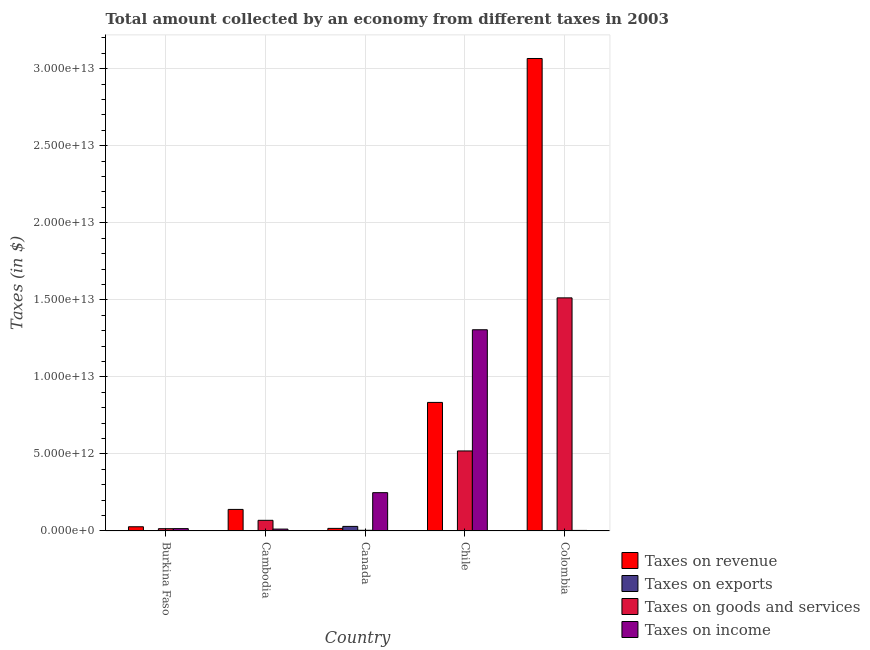How many different coloured bars are there?
Keep it short and to the point. 4. Are the number of bars per tick equal to the number of legend labels?
Your answer should be very brief. Yes. How many bars are there on the 4th tick from the right?
Your answer should be very brief. 4. What is the amount collected as tax on income in Chile?
Provide a succinct answer. 1.31e+13. Across all countries, what is the maximum amount collected as tax on income?
Your answer should be very brief. 1.31e+13. Across all countries, what is the minimum amount collected as tax on income?
Your answer should be very brief. 3.44e+1. In which country was the amount collected as tax on goods maximum?
Your answer should be very brief. Colombia. In which country was the amount collected as tax on exports minimum?
Your response must be concise. Chile. What is the total amount collected as tax on revenue in the graph?
Your answer should be very brief. 4.08e+13. What is the difference between the amount collected as tax on revenue in Burkina Faso and that in Colombia?
Offer a very short reply. -3.04e+13. What is the difference between the amount collected as tax on exports in Burkina Faso and the amount collected as tax on income in Canada?
Your answer should be compact. -2.48e+12. What is the average amount collected as tax on revenue per country?
Offer a terse response. 8.17e+12. What is the difference between the amount collected as tax on goods and amount collected as tax on revenue in Colombia?
Your answer should be compact. -1.55e+13. What is the ratio of the amount collected as tax on goods in Burkina Faso to that in Canada?
Offer a terse response. 3.5. Is the amount collected as tax on exports in Canada less than that in Chile?
Your answer should be very brief. No. What is the difference between the highest and the second highest amount collected as tax on revenue?
Offer a very short reply. 2.23e+13. What is the difference between the highest and the lowest amount collected as tax on goods?
Offer a terse response. 1.51e+13. In how many countries, is the amount collected as tax on goods greater than the average amount collected as tax on goods taken over all countries?
Your answer should be very brief. 2. Is it the case that in every country, the sum of the amount collected as tax on goods and amount collected as tax on revenue is greater than the sum of amount collected as tax on income and amount collected as tax on exports?
Offer a terse response. No. What does the 2nd bar from the left in Chile represents?
Provide a short and direct response. Taxes on exports. What does the 3rd bar from the right in Canada represents?
Keep it short and to the point. Taxes on exports. Are all the bars in the graph horizontal?
Ensure brevity in your answer.  No. How many countries are there in the graph?
Offer a very short reply. 5. What is the difference between two consecutive major ticks on the Y-axis?
Provide a short and direct response. 5.00e+12. Does the graph contain any zero values?
Provide a short and direct response. No. Where does the legend appear in the graph?
Ensure brevity in your answer.  Bottom right. What is the title of the graph?
Ensure brevity in your answer.  Total amount collected by an economy from different taxes in 2003. What is the label or title of the Y-axis?
Give a very brief answer. Taxes (in $). What is the Taxes (in $) in Taxes on revenue in Burkina Faso?
Your response must be concise. 2.71e+11. What is the Taxes (in $) in Taxes on exports in Burkina Faso?
Provide a short and direct response. 8.56e+08. What is the Taxes (in $) in Taxes on goods and services in Burkina Faso?
Keep it short and to the point. 1.47e+11. What is the Taxes (in $) in Taxes on income in Burkina Faso?
Offer a very short reply. 1.50e+11. What is the Taxes (in $) of Taxes on revenue in Cambodia?
Offer a very short reply. 1.40e+12. What is the Taxes (in $) of Taxes on exports in Cambodia?
Provide a succinct answer. 1.28e+09. What is the Taxes (in $) of Taxes on goods and services in Cambodia?
Offer a very short reply. 6.89e+11. What is the Taxes (in $) of Taxes on income in Cambodia?
Ensure brevity in your answer.  1.21e+11. What is the Taxes (in $) in Taxes on revenue in Canada?
Your answer should be compact. 1.66e+11. What is the Taxes (in $) in Taxes on exports in Canada?
Offer a terse response. 2.95e+11. What is the Taxes (in $) in Taxes on goods and services in Canada?
Ensure brevity in your answer.  4.21e+1. What is the Taxes (in $) in Taxes on income in Canada?
Your answer should be compact. 2.48e+12. What is the Taxes (in $) of Taxes on revenue in Chile?
Offer a terse response. 8.34e+12. What is the Taxes (in $) of Taxes on exports in Chile?
Your answer should be compact. 1.00e+06. What is the Taxes (in $) in Taxes on goods and services in Chile?
Offer a very short reply. 5.19e+12. What is the Taxes (in $) in Taxes on income in Chile?
Offer a very short reply. 1.31e+13. What is the Taxes (in $) of Taxes on revenue in Colombia?
Your answer should be very brief. 3.07e+13. What is the Taxes (in $) in Taxes on exports in Colombia?
Your response must be concise. 3.00e+06. What is the Taxes (in $) in Taxes on goods and services in Colombia?
Keep it short and to the point. 1.51e+13. What is the Taxes (in $) of Taxes on income in Colombia?
Provide a succinct answer. 3.44e+1. Across all countries, what is the maximum Taxes (in $) in Taxes on revenue?
Ensure brevity in your answer.  3.07e+13. Across all countries, what is the maximum Taxes (in $) of Taxes on exports?
Your answer should be compact. 2.95e+11. Across all countries, what is the maximum Taxes (in $) in Taxes on goods and services?
Offer a very short reply. 1.51e+13. Across all countries, what is the maximum Taxes (in $) of Taxes on income?
Your response must be concise. 1.31e+13. Across all countries, what is the minimum Taxes (in $) of Taxes on revenue?
Provide a short and direct response. 1.66e+11. Across all countries, what is the minimum Taxes (in $) in Taxes on exports?
Your answer should be compact. 1.00e+06. Across all countries, what is the minimum Taxes (in $) of Taxes on goods and services?
Your answer should be compact. 4.21e+1. Across all countries, what is the minimum Taxes (in $) in Taxes on income?
Your answer should be compact. 3.44e+1. What is the total Taxes (in $) of Taxes on revenue in the graph?
Make the answer very short. 4.08e+13. What is the total Taxes (in $) of Taxes on exports in the graph?
Offer a terse response. 2.97e+11. What is the total Taxes (in $) in Taxes on goods and services in the graph?
Your answer should be very brief. 2.12e+13. What is the total Taxes (in $) of Taxes on income in the graph?
Ensure brevity in your answer.  1.58e+13. What is the difference between the Taxes (in $) in Taxes on revenue in Burkina Faso and that in Cambodia?
Keep it short and to the point. -1.13e+12. What is the difference between the Taxes (in $) of Taxes on exports in Burkina Faso and that in Cambodia?
Offer a very short reply. -4.27e+08. What is the difference between the Taxes (in $) in Taxes on goods and services in Burkina Faso and that in Cambodia?
Offer a terse response. -5.42e+11. What is the difference between the Taxes (in $) in Taxes on income in Burkina Faso and that in Cambodia?
Ensure brevity in your answer.  2.99e+1. What is the difference between the Taxes (in $) in Taxes on revenue in Burkina Faso and that in Canada?
Keep it short and to the point. 1.05e+11. What is the difference between the Taxes (in $) in Taxes on exports in Burkina Faso and that in Canada?
Provide a short and direct response. -2.94e+11. What is the difference between the Taxes (in $) of Taxes on goods and services in Burkina Faso and that in Canada?
Provide a succinct answer. 1.05e+11. What is the difference between the Taxes (in $) of Taxes on income in Burkina Faso and that in Canada?
Your answer should be compact. -2.33e+12. What is the difference between the Taxes (in $) in Taxes on revenue in Burkina Faso and that in Chile?
Your answer should be very brief. -8.07e+12. What is the difference between the Taxes (in $) in Taxes on exports in Burkina Faso and that in Chile?
Make the answer very short. 8.55e+08. What is the difference between the Taxes (in $) in Taxes on goods and services in Burkina Faso and that in Chile?
Provide a succinct answer. -5.04e+12. What is the difference between the Taxes (in $) of Taxes on income in Burkina Faso and that in Chile?
Your answer should be compact. -1.29e+13. What is the difference between the Taxes (in $) in Taxes on revenue in Burkina Faso and that in Colombia?
Keep it short and to the point. -3.04e+13. What is the difference between the Taxes (in $) in Taxes on exports in Burkina Faso and that in Colombia?
Ensure brevity in your answer.  8.53e+08. What is the difference between the Taxes (in $) of Taxes on goods and services in Burkina Faso and that in Colombia?
Provide a succinct answer. -1.50e+13. What is the difference between the Taxes (in $) in Taxes on income in Burkina Faso and that in Colombia?
Provide a short and direct response. 1.16e+11. What is the difference between the Taxes (in $) of Taxes on revenue in Cambodia and that in Canada?
Provide a succinct answer. 1.23e+12. What is the difference between the Taxes (in $) of Taxes on exports in Cambodia and that in Canada?
Your answer should be very brief. -2.94e+11. What is the difference between the Taxes (in $) in Taxes on goods and services in Cambodia and that in Canada?
Your response must be concise. 6.47e+11. What is the difference between the Taxes (in $) of Taxes on income in Cambodia and that in Canada?
Your response must be concise. -2.36e+12. What is the difference between the Taxes (in $) in Taxes on revenue in Cambodia and that in Chile?
Your answer should be compact. -6.94e+12. What is the difference between the Taxes (in $) of Taxes on exports in Cambodia and that in Chile?
Offer a terse response. 1.28e+09. What is the difference between the Taxes (in $) of Taxes on goods and services in Cambodia and that in Chile?
Your answer should be very brief. -4.50e+12. What is the difference between the Taxes (in $) of Taxes on income in Cambodia and that in Chile?
Offer a very short reply. -1.29e+13. What is the difference between the Taxes (in $) of Taxes on revenue in Cambodia and that in Colombia?
Ensure brevity in your answer.  -2.93e+13. What is the difference between the Taxes (in $) of Taxes on exports in Cambodia and that in Colombia?
Provide a succinct answer. 1.28e+09. What is the difference between the Taxes (in $) in Taxes on goods and services in Cambodia and that in Colombia?
Offer a terse response. -1.44e+13. What is the difference between the Taxes (in $) of Taxes on income in Cambodia and that in Colombia?
Ensure brevity in your answer.  8.62e+1. What is the difference between the Taxes (in $) in Taxes on revenue in Canada and that in Chile?
Offer a very short reply. -8.18e+12. What is the difference between the Taxes (in $) in Taxes on exports in Canada and that in Chile?
Make the answer very short. 2.95e+11. What is the difference between the Taxes (in $) of Taxes on goods and services in Canada and that in Chile?
Give a very brief answer. -5.15e+12. What is the difference between the Taxes (in $) in Taxes on income in Canada and that in Chile?
Your answer should be very brief. -1.06e+13. What is the difference between the Taxes (in $) of Taxes on revenue in Canada and that in Colombia?
Offer a very short reply. -3.05e+13. What is the difference between the Taxes (in $) of Taxes on exports in Canada and that in Colombia?
Keep it short and to the point. 2.95e+11. What is the difference between the Taxes (in $) in Taxes on goods and services in Canada and that in Colombia?
Give a very brief answer. -1.51e+13. What is the difference between the Taxes (in $) in Taxes on income in Canada and that in Colombia?
Your answer should be very brief. 2.45e+12. What is the difference between the Taxes (in $) of Taxes on revenue in Chile and that in Colombia?
Offer a very short reply. -2.23e+13. What is the difference between the Taxes (in $) of Taxes on exports in Chile and that in Colombia?
Make the answer very short. -2.00e+06. What is the difference between the Taxes (in $) in Taxes on goods and services in Chile and that in Colombia?
Make the answer very short. -9.93e+12. What is the difference between the Taxes (in $) in Taxes on income in Chile and that in Colombia?
Provide a short and direct response. 1.30e+13. What is the difference between the Taxes (in $) of Taxes on revenue in Burkina Faso and the Taxes (in $) of Taxes on exports in Cambodia?
Give a very brief answer. 2.70e+11. What is the difference between the Taxes (in $) of Taxes on revenue in Burkina Faso and the Taxes (in $) of Taxes on goods and services in Cambodia?
Provide a short and direct response. -4.18e+11. What is the difference between the Taxes (in $) in Taxes on revenue in Burkina Faso and the Taxes (in $) in Taxes on income in Cambodia?
Offer a very short reply. 1.51e+11. What is the difference between the Taxes (in $) of Taxes on exports in Burkina Faso and the Taxes (in $) of Taxes on goods and services in Cambodia?
Keep it short and to the point. -6.89e+11. What is the difference between the Taxes (in $) of Taxes on exports in Burkina Faso and the Taxes (in $) of Taxes on income in Cambodia?
Your answer should be very brief. -1.20e+11. What is the difference between the Taxes (in $) of Taxes on goods and services in Burkina Faso and the Taxes (in $) of Taxes on income in Cambodia?
Provide a succinct answer. 2.67e+1. What is the difference between the Taxes (in $) in Taxes on revenue in Burkina Faso and the Taxes (in $) in Taxes on exports in Canada?
Make the answer very short. -2.37e+1. What is the difference between the Taxes (in $) in Taxes on revenue in Burkina Faso and the Taxes (in $) in Taxes on goods and services in Canada?
Your response must be concise. 2.29e+11. What is the difference between the Taxes (in $) in Taxes on revenue in Burkina Faso and the Taxes (in $) in Taxes on income in Canada?
Your answer should be compact. -2.21e+12. What is the difference between the Taxes (in $) in Taxes on exports in Burkina Faso and the Taxes (in $) in Taxes on goods and services in Canada?
Your answer should be compact. -4.12e+1. What is the difference between the Taxes (in $) of Taxes on exports in Burkina Faso and the Taxes (in $) of Taxes on income in Canada?
Keep it short and to the point. -2.48e+12. What is the difference between the Taxes (in $) of Taxes on goods and services in Burkina Faso and the Taxes (in $) of Taxes on income in Canada?
Make the answer very short. -2.34e+12. What is the difference between the Taxes (in $) of Taxes on revenue in Burkina Faso and the Taxes (in $) of Taxes on exports in Chile?
Ensure brevity in your answer.  2.71e+11. What is the difference between the Taxes (in $) of Taxes on revenue in Burkina Faso and the Taxes (in $) of Taxes on goods and services in Chile?
Your answer should be compact. -4.92e+12. What is the difference between the Taxes (in $) in Taxes on revenue in Burkina Faso and the Taxes (in $) in Taxes on income in Chile?
Ensure brevity in your answer.  -1.28e+13. What is the difference between the Taxes (in $) in Taxes on exports in Burkina Faso and the Taxes (in $) in Taxes on goods and services in Chile?
Your answer should be compact. -5.19e+12. What is the difference between the Taxes (in $) in Taxes on exports in Burkina Faso and the Taxes (in $) in Taxes on income in Chile?
Provide a succinct answer. -1.31e+13. What is the difference between the Taxes (in $) in Taxes on goods and services in Burkina Faso and the Taxes (in $) in Taxes on income in Chile?
Keep it short and to the point. -1.29e+13. What is the difference between the Taxes (in $) in Taxes on revenue in Burkina Faso and the Taxes (in $) in Taxes on exports in Colombia?
Offer a terse response. 2.71e+11. What is the difference between the Taxes (in $) in Taxes on revenue in Burkina Faso and the Taxes (in $) in Taxes on goods and services in Colombia?
Your response must be concise. -1.49e+13. What is the difference between the Taxes (in $) in Taxes on revenue in Burkina Faso and the Taxes (in $) in Taxes on income in Colombia?
Your response must be concise. 2.37e+11. What is the difference between the Taxes (in $) in Taxes on exports in Burkina Faso and the Taxes (in $) in Taxes on goods and services in Colombia?
Your answer should be very brief. -1.51e+13. What is the difference between the Taxes (in $) of Taxes on exports in Burkina Faso and the Taxes (in $) of Taxes on income in Colombia?
Offer a very short reply. -3.35e+1. What is the difference between the Taxes (in $) in Taxes on goods and services in Burkina Faso and the Taxes (in $) in Taxes on income in Colombia?
Provide a succinct answer. 1.13e+11. What is the difference between the Taxes (in $) in Taxes on revenue in Cambodia and the Taxes (in $) in Taxes on exports in Canada?
Your answer should be very brief. 1.10e+12. What is the difference between the Taxes (in $) in Taxes on revenue in Cambodia and the Taxes (in $) in Taxes on goods and services in Canada?
Ensure brevity in your answer.  1.36e+12. What is the difference between the Taxes (in $) in Taxes on revenue in Cambodia and the Taxes (in $) in Taxes on income in Canada?
Give a very brief answer. -1.09e+12. What is the difference between the Taxes (in $) of Taxes on exports in Cambodia and the Taxes (in $) of Taxes on goods and services in Canada?
Provide a short and direct response. -4.08e+1. What is the difference between the Taxes (in $) of Taxes on exports in Cambodia and the Taxes (in $) of Taxes on income in Canada?
Keep it short and to the point. -2.48e+12. What is the difference between the Taxes (in $) in Taxes on goods and services in Cambodia and the Taxes (in $) in Taxes on income in Canada?
Ensure brevity in your answer.  -1.80e+12. What is the difference between the Taxes (in $) of Taxes on revenue in Cambodia and the Taxes (in $) of Taxes on exports in Chile?
Your answer should be very brief. 1.40e+12. What is the difference between the Taxes (in $) in Taxes on revenue in Cambodia and the Taxes (in $) in Taxes on goods and services in Chile?
Your answer should be very brief. -3.79e+12. What is the difference between the Taxes (in $) of Taxes on revenue in Cambodia and the Taxes (in $) of Taxes on income in Chile?
Your answer should be very brief. -1.17e+13. What is the difference between the Taxes (in $) in Taxes on exports in Cambodia and the Taxes (in $) in Taxes on goods and services in Chile?
Keep it short and to the point. -5.19e+12. What is the difference between the Taxes (in $) in Taxes on exports in Cambodia and the Taxes (in $) in Taxes on income in Chile?
Your response must be concise. -1.31e+13. What is the difference between the Taxes (in $) of Taxes on goods and services in Cambodia and the Taxes (in $) of Taxes on income in Chile?
Make the answer very short. -1.24e+13. What is the difference between the Taxes (in $) in Taxes on revenue in Cambodia and the Taxes (in $) in Taxes on exports in Colombia?
Keep it short and to the point. 1.40e+12. What is the difference between the Taxes (in $) in Taxes on revenue in Cambodia and the Taxes (in $) in Taxes on goods and services in Colombia?
Keep it short and to the point. -1.37e+13. What is the difference between the Taxes (in $) of Taxes on revenue in Cambodia and the Taxes (in $) of Taxes on income in Colombia?
Provide a succinct answer. 1.36e+12. What is the difference between the Taxes (in $) of Taxes on exports in Cambodia and the Taxes (in $) of Taxes on goods and services in Colombia?
Your response must be concise. -1.51e+13. What is the difference between the Taxes (in $) in Taxes on exports in Cambodia and the Taxes (in $) in Taxes on income in Colombia?
Give a very brief answer. -3.31e+1. What is the difference between the Taxes (in $) in Taxes on goods and services in Cambodia and the Taxes (in $) in Taxes on income in Colombia?
Offer a very short reply. 6.55e+11. What is the difference between the Taxes (in $) in Taxes on revenue in Canada and the Taxes (in $) in Taxes on exports in Chile?
Provide a succinct answer. 1.66e+11. What is the difference between the Taxes (in $) in Taxes on revenue in Canada and the Taxes (in $) in Taxes on goods and services in Chile?
Offer a terse response. -5.03e+12. What is the difference between the Taxes (in $) in Taxes on revenue in Canada and the Taxes (in $) in Taxes on income in Chile?
Offer a very short reply. -1.29e+13. What is the difference between the Taxes (in $) in Taxes on exports in Canada and the Taxes (in $) in Taxes on goods and services in Chile?
Your answer should be compact. -4.90e+12. What is the difference between the Taxes (in $) of Taxes on exports in Canada and the Taxes (in $) of Taxes on income in Chile?
Ensure brevity in your answer.  -1.28e+13. What is the difference between the Taxes (in $) in Taxes on goods and services in Canada and the Taxes (in $) in Taxes on income in Chile?
Provide a succinct answer. -1.30e+13. What is the difference between the Taxes (in $) of Taxes on revenue in Canada and the Taxes (in $) of Taxes on exports in Colombia?
Provide a short and direct response. 1.66e+11. What is the difference between the Taxes (in $) in Taxes on revenue in Canada and the Taxes (in $) in Taxes on goods and services in Colombia?
Give a very brief answer. -1.50e+13. What is the difference between the Taxes (in $) of Taxes on revenue in Canada and the Taxes (in $) of Taxes on income in Colombia?
Make the answer very short. 1.31e+11. What is the difference between the Taxes (in $) of Taxes on exports in Canada and the Taxes (in $) of Taxes on goods and services in Colombia?
Give a very brief answer. -1.48e+13. What is the difference between the Taxes (in $) of Taxes on exports in Canada and the Taxes (in $) of Taxes on income in Colombia?
Make the answer very short. 2.60e+11. What is the difference between the Taxes (in $) in Taxes on goods and services in Canada and the Taxes (in $) in Taxes on income in Colombia?
Offer a very short reply. 7.70e+09. What is the difference between the Taxes (in $) in Taxes on revenue in Chile and the Taxes (in $) in Taxes on exports in Colombia?
Offer a very short reply. 8.34e+12. What is the difference between the Taxes (in $) of Taxes on revenue in Chile and the Taxes (in $) of Taxes on goods and services in Colombia?
Provide a short and direct response. -6.79e+12. What is the difference between the Taxes (in $) in Taxes on revenue in Chile and the Taxes (in $) in Taxes on income in Colombia?
Ensure brevity in your answer.  8.31e+12. What is the difference between the Taxes (in $) of Taxes on exports in Chile and the Taxes (in $) of Taxes on goods and services in Colombia?
Offer a terse response. -1.51e+13. What is the difference between the Taxes (in $) of Taxes on exports in Chile and the Taxes (in $) of Taxes on income in Colombia?
Offer a very short reply. -3.44e+1. What is the difference between the Taxes (in $) in Taxes on goods and services in Chile and the Taxes (in $) in Taxes on income in Colombia?
Keep it short and to the point. 5.16e+12. What is the average Taxes (in $) of Taxes on revenue per country?
Make the answer very short. 8.17e+12. What is the average Taxes (in $) in Taxes on exports per country?
Your answer should be very brief. 5.94e+1. What is the average Taxes (in $) of Taxes on goods and services per country?
Provide a short and direct response. 4.24e+12. What is the average Taxes (in $) in Taxes on income per country?
Make the answer very short. 3.17e+12. What is the difference between the Taxes (in $) in Taxes on revenue and Taxes (in $) in Taxes on exports in Burkina Faso?
Give a very brief answer. 2.70e+11. What is the difference between the Taxes (in $) of Taxes on revenue and Taxes (in $) of Taxes on goods and services in Burkina Faso?
Provide a succinct answer. 1.24e+11. What is the difference between the Taxes (in $) in Taxes on revenue and Taxes (in $) in Taxes on income in Burkina Faso?
Offer a terse response. 1.21e+11. What is the difference between the Taxes (in $) in Taxes on exports and Taxes (in $) in Taxes on goods and services in Burkina Faso?
Make the answer very short. -1.46e+11. What is the difference between the Taxes (in $) of Taxes on exports and Taxes (in $) of Taxes on income in Burkina Faso?
Offer a terse response. -1.50e+11. What is the difference between the Taxes (in $) in Taxes on goods and services and Taxes (in $) in Taxes on income in Burkina Faso?
Offer a terse response. -3.21e+09. What is the difference between the Taxes (in $) in Taxes on revenue and Taxes (in $) in Taxes on exports in Cambodia?
Give a very brief answer. 1.40e+12. What is the difference between the Taxes (in $) of Taxes on revenue and Taxes (in $) of Taxes on goods and services in Cambodia?
Your answer should be compact. 7.08e+11. What is the difference between the Taxes (in $) in Taxes on revenue and Taxes (in $) in Taxes on income in Cambodia?
Keep it short and to the point. 1.28e+12. What is the difference between the Taxes (in $) in Taxes on exports and Taxes (in $) in Taxes on goods and services in Cambodia?
Your response must be concise. -6.88e+11. What is the difference between the Taxes (in $) of Taxes on exports and Taxes (in $) of Taxes on income in Cambodia?
Your answer should be very brief. -1.19e+11. What is the difference between the Taxes (in $) in Taxes on goods and services and Taxes (in $) in Taxes on income in Cambodia?
Keep it short and to the point. 5.69e+11. What is the difference between the Taxes (in $) of Taxes on revenue and Taxes (in $) of Taxes on exports in Canada?
Keep it short and to the point. -1.29e+11. What is the difference between the Taxes (in $) of Taxes on revenue and Taxes (in $) of Taxes on goods and services in Canada?
Give a very brief answer. 1.24e+11. What is the difference between the Taxes (in $) of Taxes on revenue and Taxes (in $) of Taxes on income in Canada?
Your response must be concise. -2.32e+12. What is the difference between the Taxes (in $) of Taxes on exports and Taxes (in $) of Taxes on goods and services in Canada?
Make the answer very short. 2.53e+11. What is the difference between the Taxes (in $) in Taxes on exports and Taxes (in $) in Taxes on income in Canada?
Ensure brevity in your answer.  -2.19e+12. What is the difference between the Taxes (in $) in Taxes on goods and services and Taxes (in $) in Taxes on income in Canada?
Offer a terse response. -2.44e+12. What is the difference between the Taxes (in $) in Taxes on revenue and Taxes (in $) in Taxes on exports in Chile?
Offer a very short reply. 8.34e+12. What is the difference between the Taxes (in $) of Taxes on revenue and Taxes (in $) of Taxes on goods and services in Chile?
Your answer should be compact. 3.15e+12. What is the difference between the Taxes (in $) in Taxes on revenue and Taxes (in $) in Taxes on income in Chile?
Offer a very short reply. -4.72e+12. What is the difference between the Taxes (in $) in Taxes on exports and Taxes (in $) in Taxes on goods and services in Chile?
Give a very brief answer. -5.19e+12. What is the difference between the Taxes (in $) of Taxes on exports and Taxes (in $) of Taxes on income in Chile?
Offer a terse response. -1.31e+13. What is the difference between the Taxes (in $) of Taxes on goods and services and Taxes (in $) of Taxes on income in Chile?
Your answer should be compact. -7.87e+12. What is the difference between the Taxes (in $) in Taxes on revenue and Taxes (in $) in Taxes on exports in Colombia?
Keep it short and to the point. 3.07e+13. What is the difference between the Taxes (in $) of Taxes on revenue and Taxes (in $) of Taxes on goods and services in Colombia?
Offer a very short reply. 1.55e+13. What is the difference between the Taxes (in $) of Taxes on revenue and Taxes (in $) of Taxes on income in Colombia?
Offer a very short reply. 3.06e+13. What is the difference between the Taxes (in $) of Taxes on exports and Taxes (in $) of Taxes on goods and services in Colombia?
Provide a succinct answer. -1.51e+13. What is the difference between the Taxes (in $) of Taxes on exports and Taxes (in $) of Taxes on income in Colombia?
Your answer should be compact. -3.44e+1. What is the difference between the Taxes (in $) in Taxes on goods and services and Taxes (in $) in Taxes on income in Colombia?
Offer a very short reply. 1.51e+13. What is the ratio of the Taxes (in $) of Taxes on revenue in Burkina Faso to that in Cambodia?
Ensure brevity in your answer.  0.19. What is the ratio of the Taxes (in $) in Taxes on exports in Burkina Faso to that in Cambodia?
Ensure brevity in your answer.  0.67. What is the ratio of the Taxes (in $) of Taxes on goods and services in Burkina Faso to that in Cambodia?
Provide a short and direct response. 0.21. What is the ratio of the Taxes (in $) of Taxes on income in Burkina Faso to that in Cambodia?
Provide a succinct answer. 1.25. What is the ratio of the Taxes (in $) of Taxes on revenue in Burkina Faso to that in Canada?
Keep it short and to the point. 1.64. What is the ratio of the Taxes (in $) in Taxes on exports in Burkina Faso to that in Canada?
Provide a short and direct response. 0. What is the ratio of the Taxes (in $) of Taxes on goods and services in Burkina Faso to that in Canada?
Keep it short and to the point. 3.5. What is the ratio of the Taxes (in $) in Taxes on income in Burkina Faso to that in Canada?
Ensure brevity in your answer.  0.06. What is the ratio of the Taxes (in $) in Taxes on revenue in Burkina Faso to that in Chile?
Keep it short and to the point. 0.03. What is the ratio of the Taxes (in $) in Taxes on exports in Burkina Faso to that in Chile?
Offer a terse response. 855.6. What is the ratio of the Taxes (in $) of Taxes on goods and services in Burkina Faso to that in Chile?
Offer a very short reply. 0.03. What is the ratio of the Taxes (in $) in Taxes on income in Burkina Faso to that in Chile?
Offer a terse response. 0.01. What is the ratio of the Taxes (in $) in Taxes on revenue in Burkina Faso to that in Colombia?
Make the answer very short. 0.01. What is the ratio of the Taxes (in $) of Taxes on exports in Burkina Faso to that in Colombia?
Your answer should be very brief. 284.77. What is the ratio of the Taxes (in $) of Taxes on goods and services in Burkina Faso to that in Colombia?
Ensure brevity in your answer.  0.01. What is the ratio of the Taxes (in $) in Taxes on income in Burkina Faso to that in Colombia?
Keep it short and to the point. 4.37. What is the ratio of the Taxes (in $) of Taxes on revenue in Cambodia to that in Canada?
Offer a very short reply. 8.43. What is the ratio of the Taxes (in $) of Taxes on exports in Cambodia to that in Canada?
Provide a succinct answer. 0. What is the ratio of the Taxes (in $) in Taxes on goods and services in Cambodia to that in Canada?
Ensure brevity in your answer.  16.38. What is the ratio of the Taxes (in $) in Taxes on income in Cambodia to that in Canada?
Your response must be concise. 0.05. What is the ratio of the Taxes (in $) of Taxes on revenue in Cambodia to that in Chile?
Your answer should be compact. 0.17. What is the ratio of the Taxes (in $) of Taxes on exports in Cambodia to that in Chile?
Provide a succinct answer. 1282.92. What is the ratio of the Taxes (in $) of Taxes on goods and services in Cambodia to that in Chile?
Make the answer very short. 0.13. What is the ratio of the Taxes (in $) of Taxes on income in Cambodia to that in Chile?
Ensure brevity in your answer.  0.01. What is the ratio of the Taxes (in $) in Taxes on revenue in Cambodia to that in Colombia?
Provide a succinct answer. 0.05. What is the ratio of the Taxes (in $) of Taxes on exports in Cambodia to that in Colombia?
Your answer should be compact. 426.99. What is the ratio of the Taxes (in $) of Taxes on goods and services in Cambodia to that in Colombia?
Keep it short and to the point. 0.05. What is the ratio of the Taxes (in $) of Taxes on income in Cambodia to that in Colombia?
Ensure brevity in your answer.  3.5. What is the ratio of the Taxes (in $) in Taxes on revenue in Canada to that in Chile?
Provide a succinct answer. 0.02. What is the ratio of the Taxes (in $) of Taxes on exports in Canada to that in Chile?
Your response must be concise. 2.95e+05. What is the ratio of the Taxes (in $) in Taxes on goods and services in Canada to that in Chile?
Offer a very short reply. 0.01. What is the ratio of the Taxes (in $) of Taxes on income in Canada to that in Chile?
Your response must be concise. 0.19. What is the ratio of the Taxes (in $) of Taxes on revenue in Canada to that in Colombia?
Ensure brevity in your answer.  0.01. What is the ratio of the Taxes (in $) of Taxes on exports in Canada to that in Colombia?
Your answer should be compact. 9.81e+04. What is the ratio of the Taxes (in $) of Taxes on goods and services in Canada to that in Colombia?
Ensure brevity in your answer.  0. What is the ratio of the Taxes (in $) of Taxes on income in Canada to that in Colombia?
Provide a short and direct response. 72.22. What is the ratio of the Taxes (in $) in Taxes on revenue in Chile to that in Colombia?
Offer a very short reply. 0.27. What is the ratio of the Taxes (in $) in Taxes on exports in Chile to that in Colombia?
Your response must be concise. 0.33. What is the ratio of the Taxes (in $) in Taxes on goods and services in Chile to that in Colombia?
Give a very brief answer. 0.34. What is the ratio of the Taxes (in $) of Taxes on income in Chile to that in Colombia?
Offer a very short reply. 379.57. What is the difference between the highest and the second highest Taxes (in $) of Taxes on revenue?
Give a very brief answer. 2.23e+13. What is the difference between the highest and the second highest Taxes (in $) in Taxes on exports?
Your answer should be compact. 2.94e+11. What is the difference between the highest and the second highest Taxes (in $) of Taxes on goods and services?
Your answer should be very brief. 9.93e+12. What is the difference between the highest and the second highest Taxes (in $) of Taxes on income?
Keep it short and to the point. 1.06e+13. What is the difference between the highest and the lowest Taxes (in $) of Taxes on revenue?
Give a very brief answer. 3.05e+13. What is the difference between the highest and the lowest Taxes (in $) of Taxes on exports?
Keep it short and to the point. 2.95e+11. What is the difference between the highest and the lowest Taxes (in $) of Taxes on goods and services?
Make the answer very short. 1.51e+13. What is the difference between the highest and the lowest Taxes (in $) of Taxes on income?
Keep it short and to the point. 1.30e+13. 